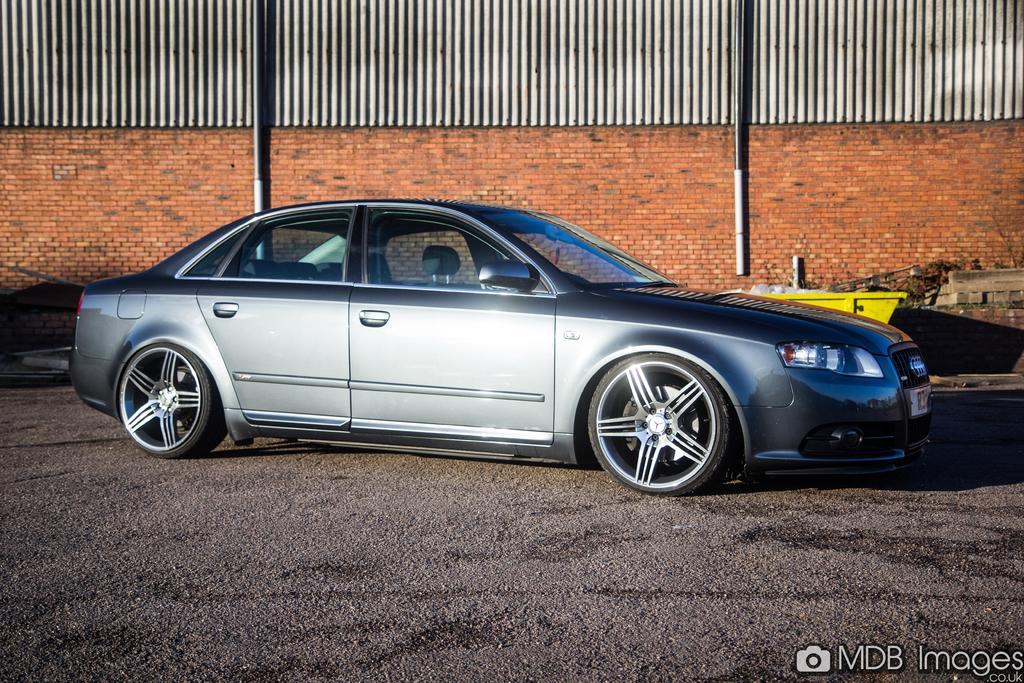In one or two sentences, can you explain what this image depicts? In the image there is a car on the ground. Behind the car there is a brick wall and also there is iron wall. And also there is a yellow color object. In the bottom right corner of the image there is a camera symbol and a name. 